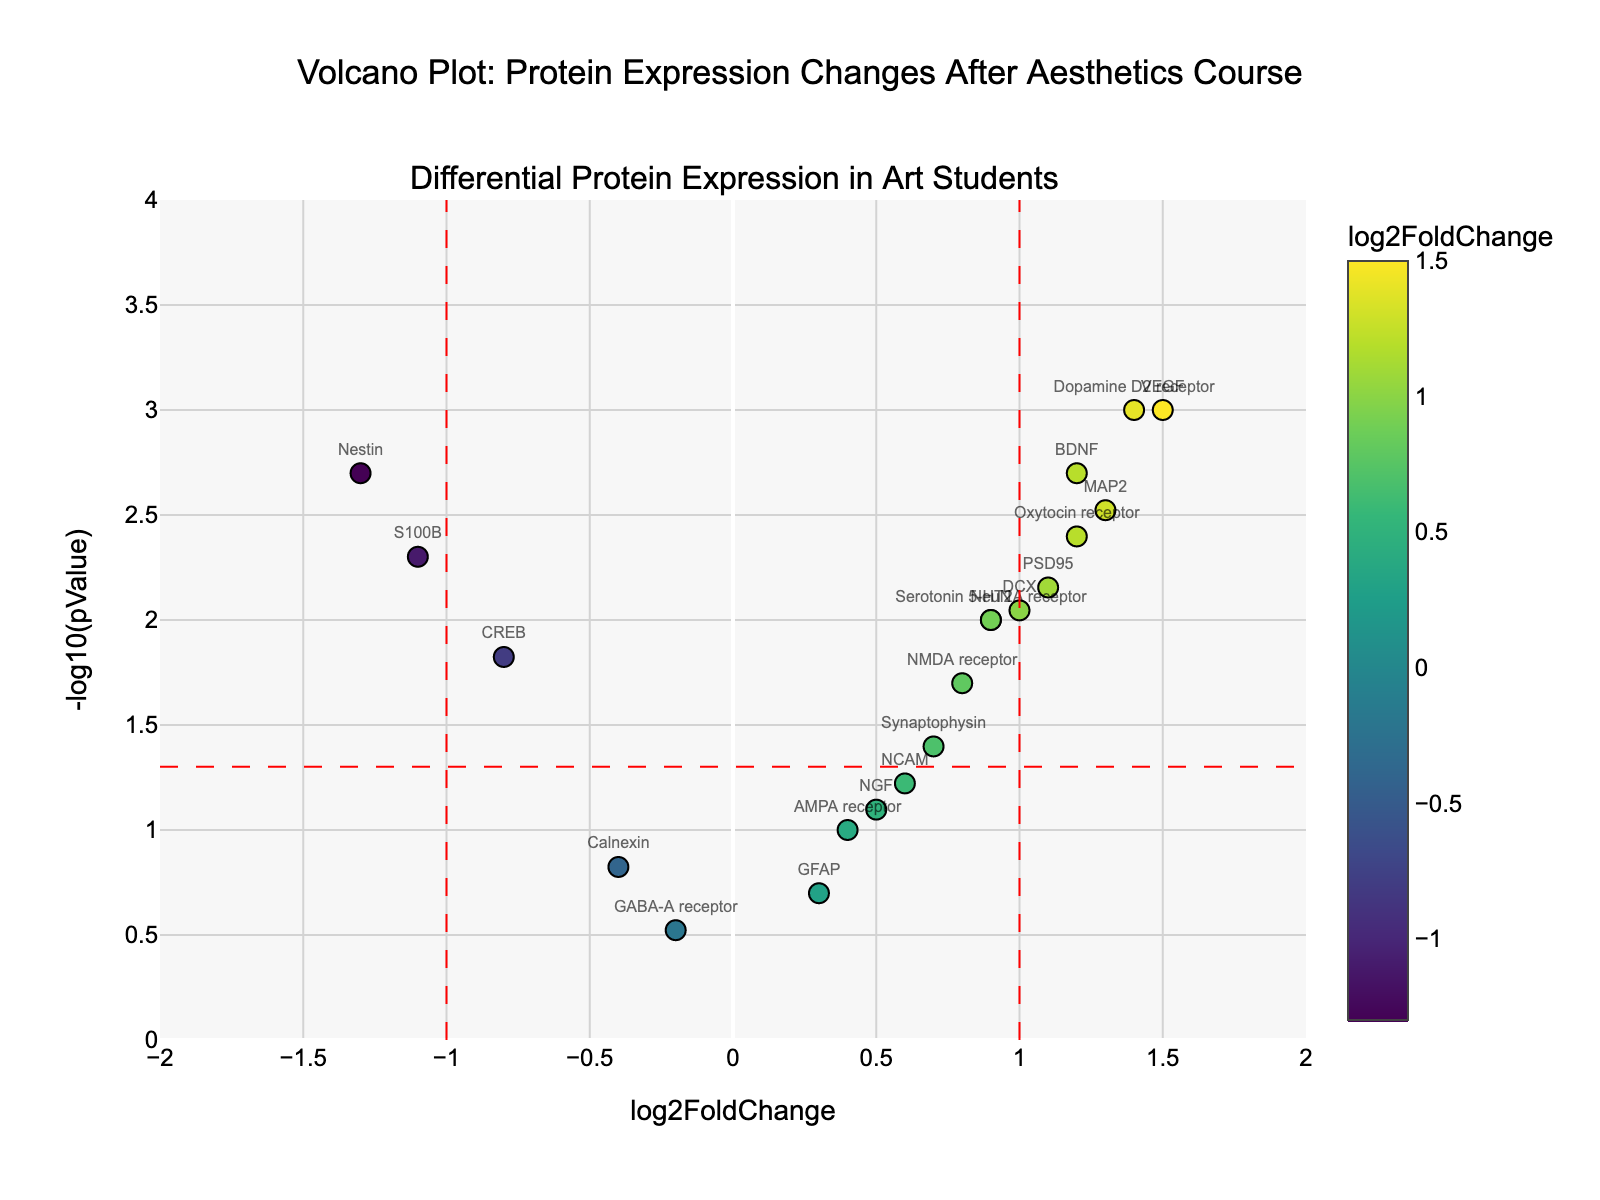What is the title of the plot? The title is located at the top center of the plot. It reads "Volcano Plot: Protein Expression Changes After Aesthetics Course."
Answer: Volcano Plot: Protein Expression Changes After Aesthetics Course What are the x-axis and y-axis labels? The labels are positioned along the respective axes in the plot. The x-axis is labeled "log2FoldChange" and the y-axis is labeled "-log10(pValue)."
Answer: x-axis: log2FoldChange, y-axis: -log10(pValue) How many proteins have a log2FoldChange greater than 1? Count the data points to the right of the vertical red line at x = 1. There are 3 such data points.
Answer: 3 Which protein has the highest -log10(pValue)? Locate the point at the highest y-axis value and check the text label. The highest -log10(pValue) corresponds to the protein Dopamine D2 receptor.
Answer: Dopamine D2 receptor What proteins are on the left of the plot with a log2FoldChange less than -1? Look to the left of the vertical red line at x = -1 and check the text labels. The proteins are S100B and Nestin.
Answer: S100B, Nestin Identify the two proteins closest to being significant by having p-values just above 0.05. Look at points with -log10(pValue) just below the red horizontal line (-log10 of 0.05). The proteins closest to this line are NGF and Calnexin.
Answer: NGF, Calnexin Which proteins have both positive log2FoldChange and significant p-values (below 0.05)? Look for points on the right side (positive log2FoldChange) that are above the red horizontal line. These points are BDNF, VEGF, NeuN, MAP2, PSD95, DCX, NMDA receptor, Serotonin 5-HT2A receptor, and Oxytocin receptor.
Answer: BDNF, VEGF, NeuN, MAP2, PSD95, DCX, NMDA receptor, Serotonin 5-HT2A receptor, Oxytocin receptor What is the average log2FoldChange of the proteins VEGF and Dopamine D2 receptor? Find the log2FoldChange values for VEGF (1.5) and Dopamine D2 receptor (1.4), then average them. (1.5 + 1.4) / 2 = 1.45
Answer: 1.45 Which protein shows the lowest log2FoldChange? Identify the data point with the lowest x-axis value. The protein with the lowest log2FoldChange is Nestin with a value of -1.3.
Answer: Nestin 